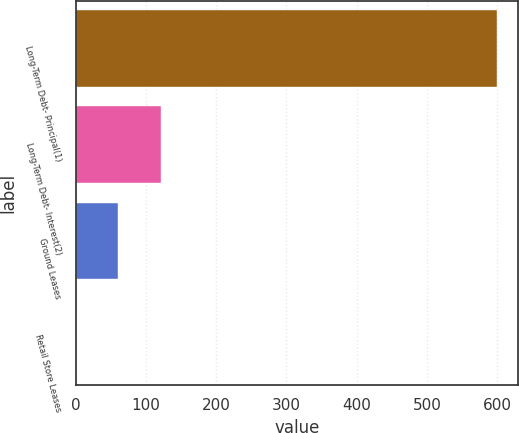Convert chart to OTSL. <chart><loc_0><loc_0><loc_500><loc_500><bar_chart><fcel>Long-Term Debt- Principal(1)<fcel>Long-Term Debt- Interest(2)<fcel>Ground Leases<fcel>Retail Store Leases<nl><fcel>599.7<fcel>120.98<fcel>61.14<fcel>1.3<nl></chart> 